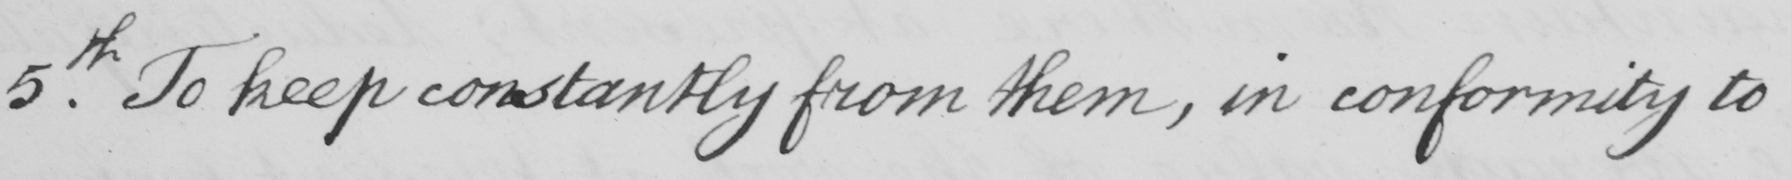Please provide the text content of this handwritten line. 5th. To keep constantly from them, in conformity to 